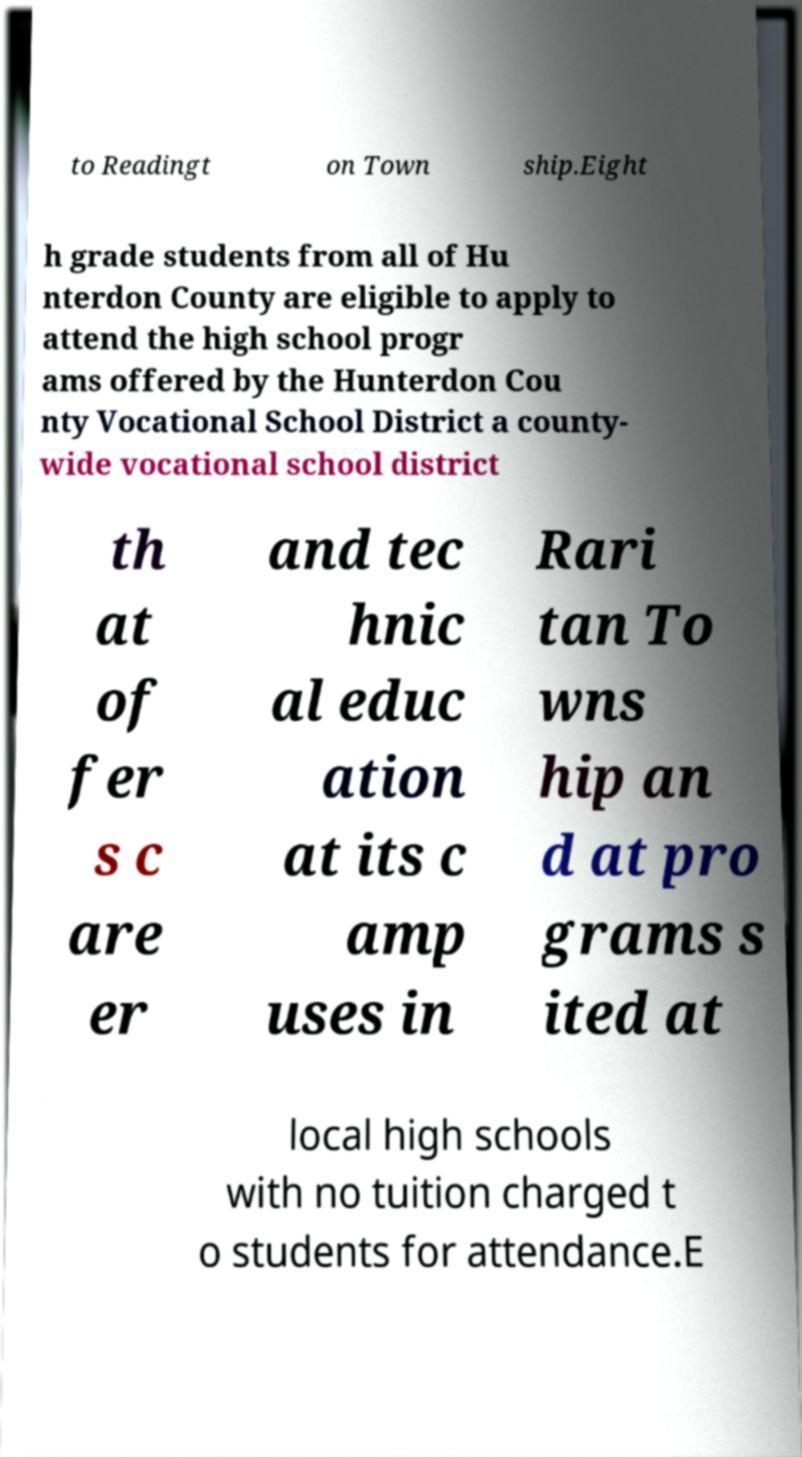I need the written content from this picture converted into text. Can you do that? to Readingt on Town ship.Eight h grade students from all of Hu nterdon County are eligible to apply to attend the high school progr ams offered by the Hunterdon Cou nty Vocational School District a county- wide vocational school district th at of fer s c are er and tec hnic al educ ation at its c amp uses in Rari tan To wns hip an d at pro grams s ited at local high schools with no tuition charged t o students for attendance.E 